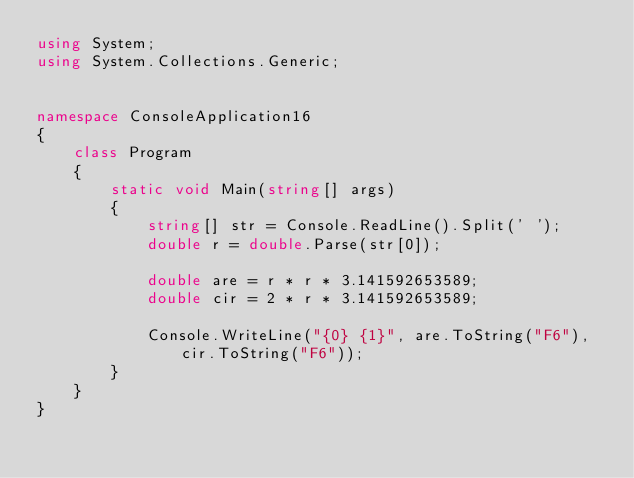<code> <loc_0><loc_0><loc_500><loc_500><_C#_>using System;
using System.Collections.Generic;


namespace ConsoleApplication16
{
    class Program
    {
        static void Main(string[] args)
        {
            string[] str = Console.ReadLine().Split(' ');
            double r = double.Parse(str[0]);

            double are = r * r * 3.141592653589;
            double cir = 2 * r * 3.141592653589;

            Console.WriteLine("{0} {1}", are.ToString("F6"), cir.ToString("F6"));
        }
    }
}</code> 